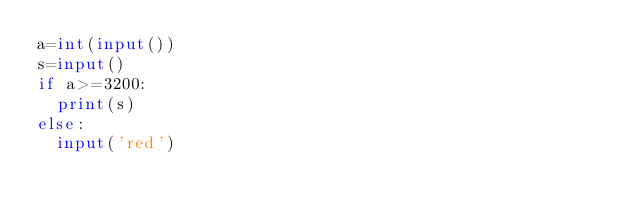Convert code to text. <code><loc_0><loc_0><loc_500><loc_500><_Python_>a=int(input())
s=input()
if a>=3200:
  print(s)
else:
  input('red')</code> 